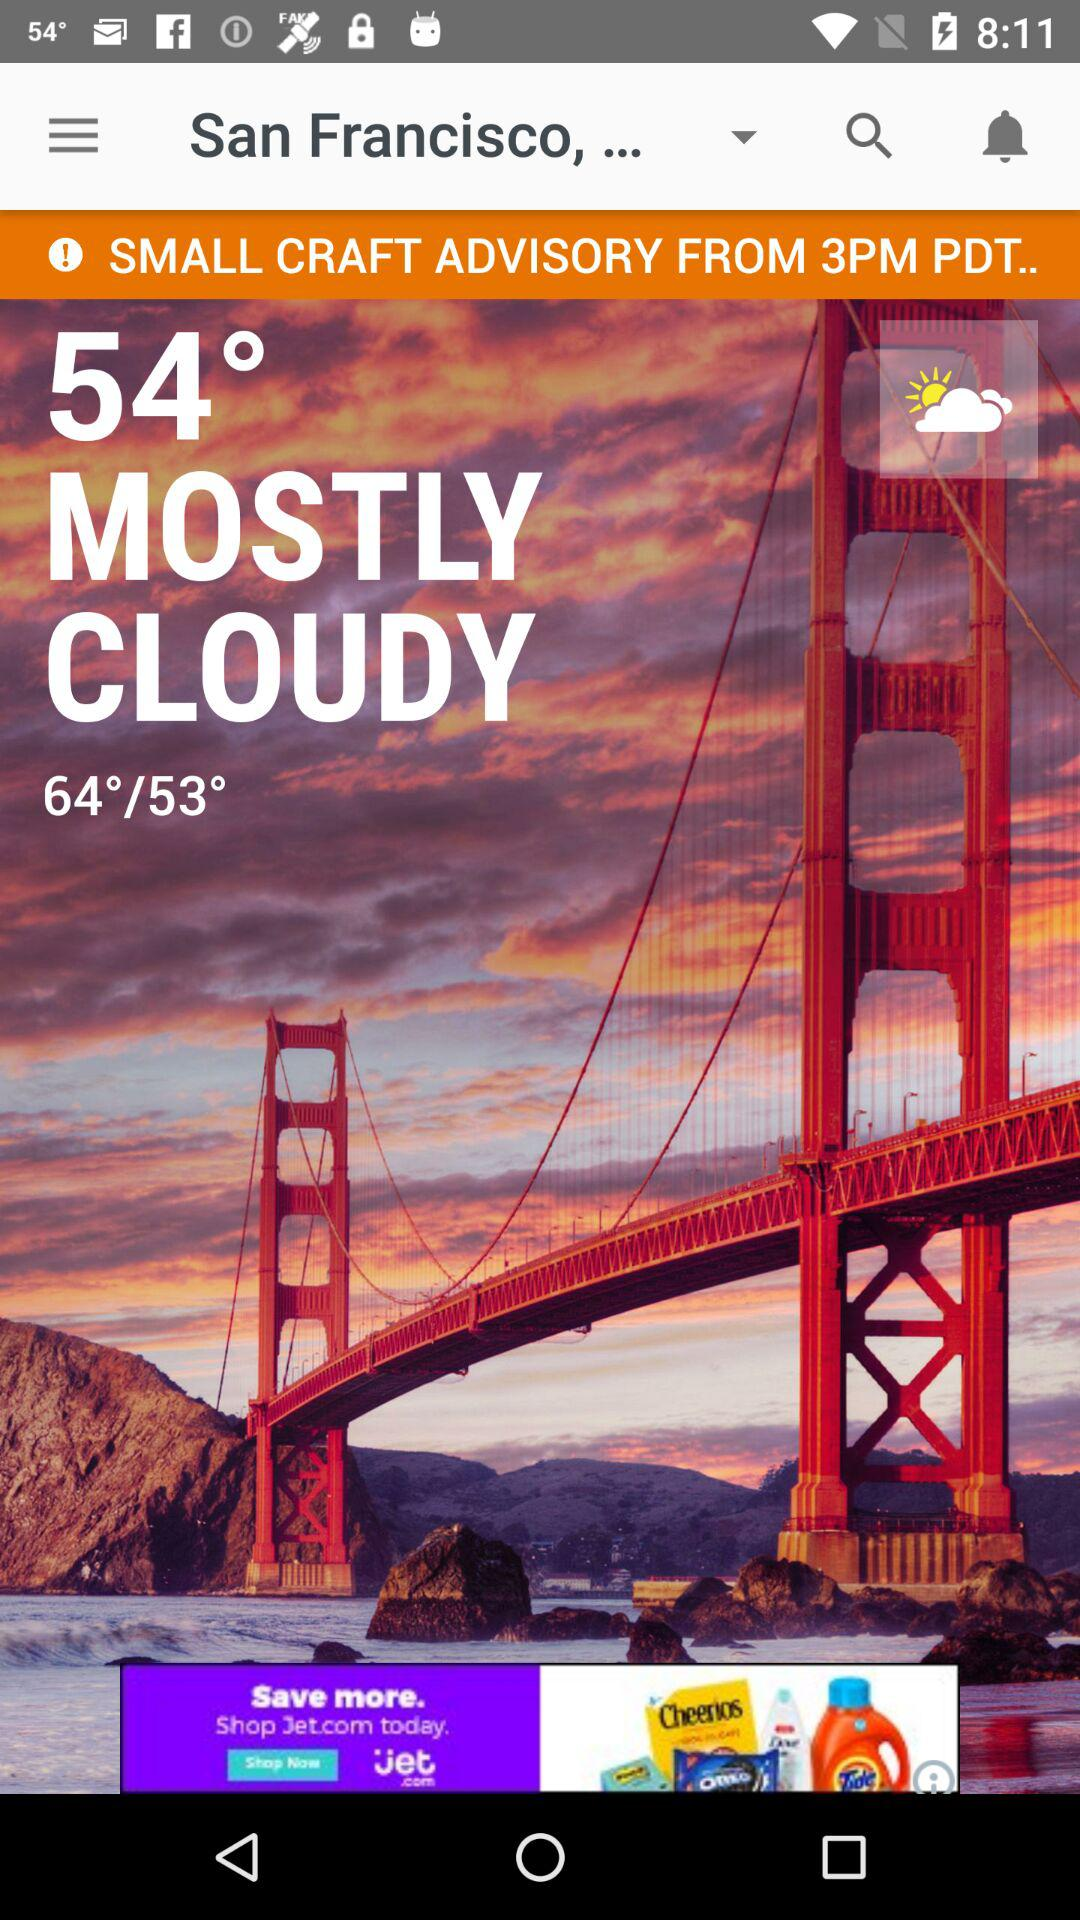What is the location? The location is "San Francisco,...". 